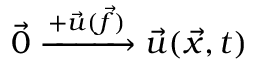<formula> <loc_0><loc_0><loc_500><loc_500>\vec { 0 } \xrightarrow { + \ V e c { u } ( \ V e c { f } ) } \ V e c { u } ( \ V e c { x } , t )</formula> 